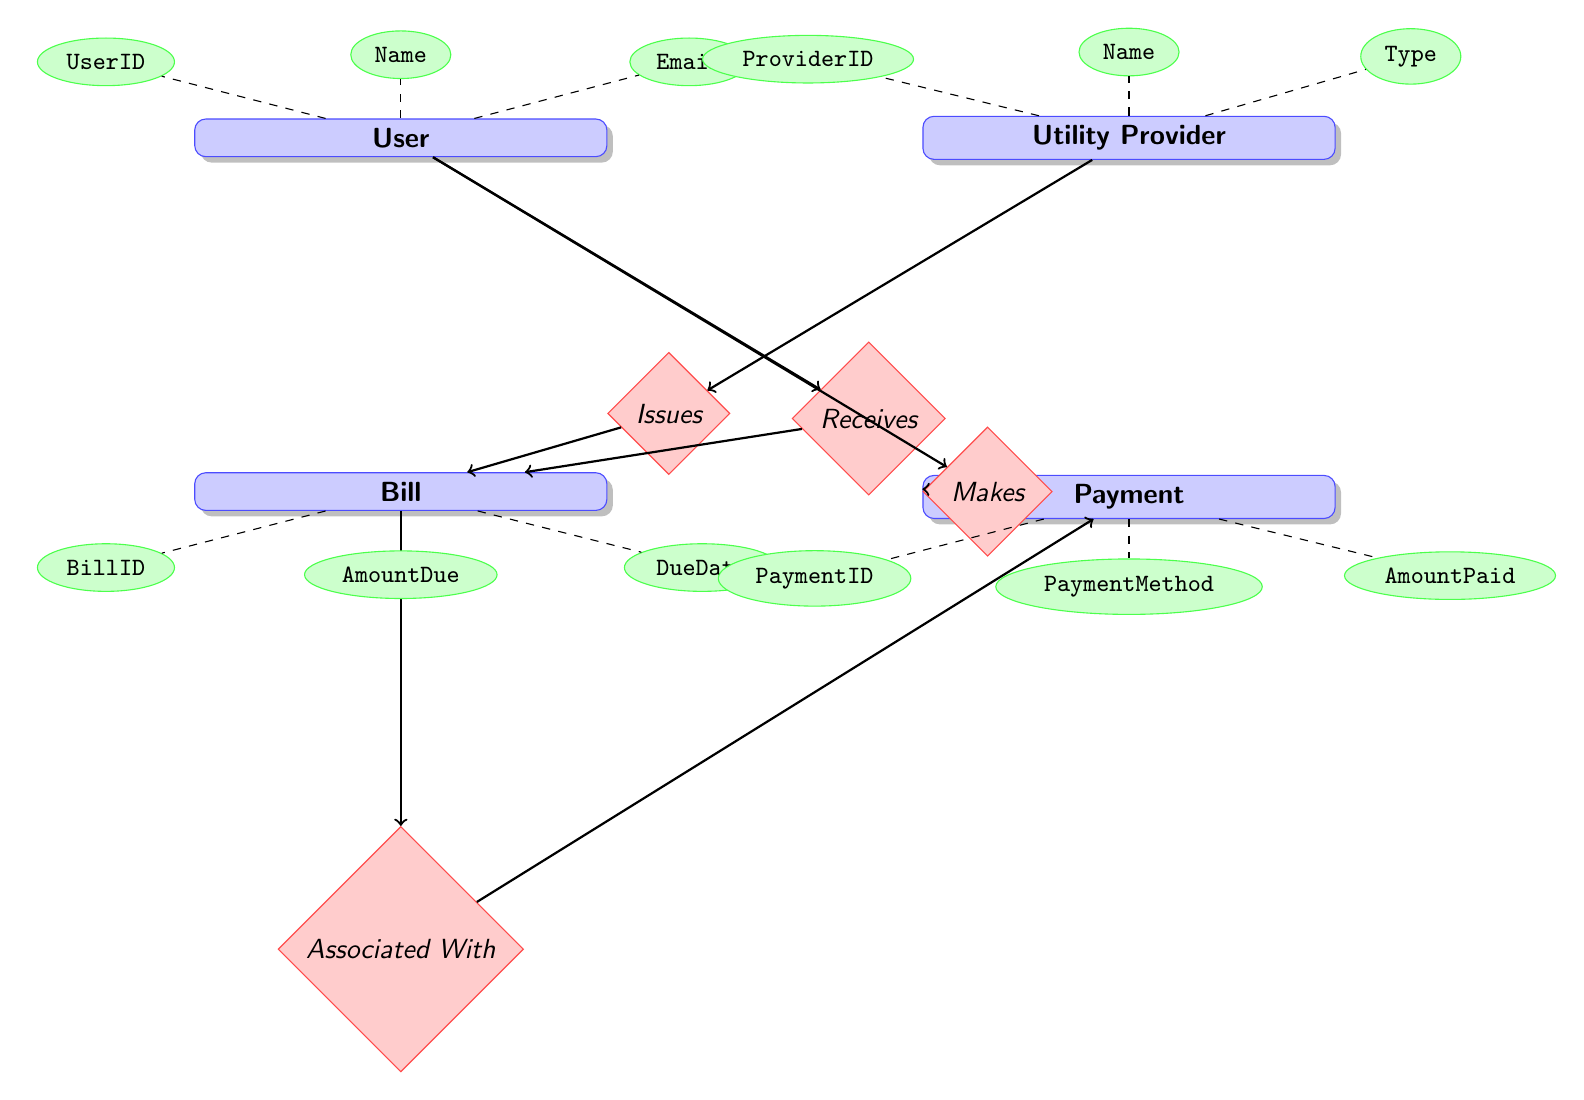What are the attributes of the User entity? The User entity has several attributes listed in the diagram: UserID, Name, Email, Password, and Address. These attributes define the information that is collected for each user within the Home Utility Bill Management System.
Answer: UserID, Name, Email, Password, Address How many entities are present in the diagram? In the provided diagram, there are four entities: User, Utility Provider, Bill, and Payment. Counting the names visually from the diagram gives us this total.
Answer: 4 What relationship connects User and Bill? The relationship that connects User and Bill is named "Receives." This is indicated by the directed edge labeled 'Receives' connecting the User entity downward to the Bill entity in the diagram.
Answer: Receives Which entity does the Payment method belong to? The Payment method is an attribute of the Payment entity. The Payment entity is connected to the User entity through the Makes relationship, indicating that a user makes a payment.
Answer: Payment What does the Bills entity associate with in terms of the Payment entity? The Bills entity is associated with the Payment entity through the "Associated With" relationship. This shows that each bill can have related payment entries.
Answer: Associated With What attribute of the Bill entity specifies the payment status? The attribute in the Bill entity that specifies the payment status is "Status." This attribute helps track whether a bill has been paid or is still outstanding.
Answer: Status How many attributes does the Utility Provider entity have? The Utility Provider entity has four attributes: ProviderID, Name, Type, and ContactInfo. This information can be counted directly from the diagram elements linked to the Utility Provider.
Answer: 4 What does the Makes relationship connect? The Makes relationship connects the User and Payment entities, indicating that a user initiates a payment action concerning their bills.
Answer: User and Payment Explain the relationship between Utility Provider and Bill. The Utility Provider and Bill are connected by the "Issues" relationship. This suggests that the utility provider is responsible for issuing the bills that users receive for their utilities.
Answer: Issues 